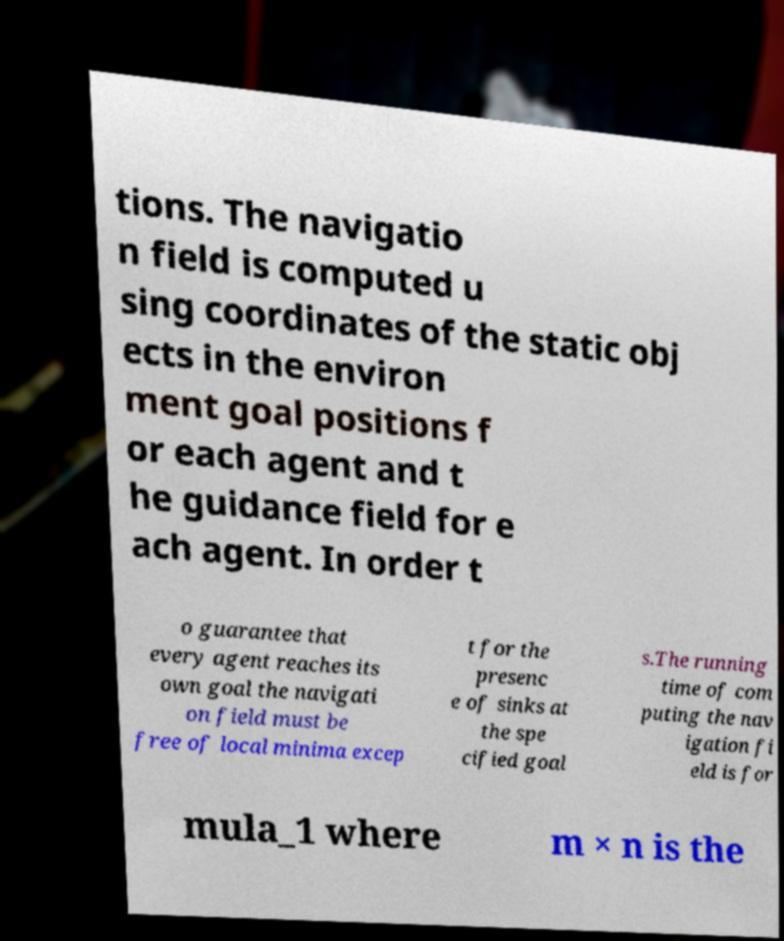Could you extract and type out the text from this image? tions. The navigatio n field is computed u sing coordinates of the static obj ects in the environ ment goal positions f or each agent and t he guidance field for e ach agent. In order t o guarantee that every agent reaches its own goal the navigati on field must be free of local minima excep t for the presenc e of sinks at the spe cified goal s.The running time of com puting the nav igation fi eld is for mula_1 where m × n is the 